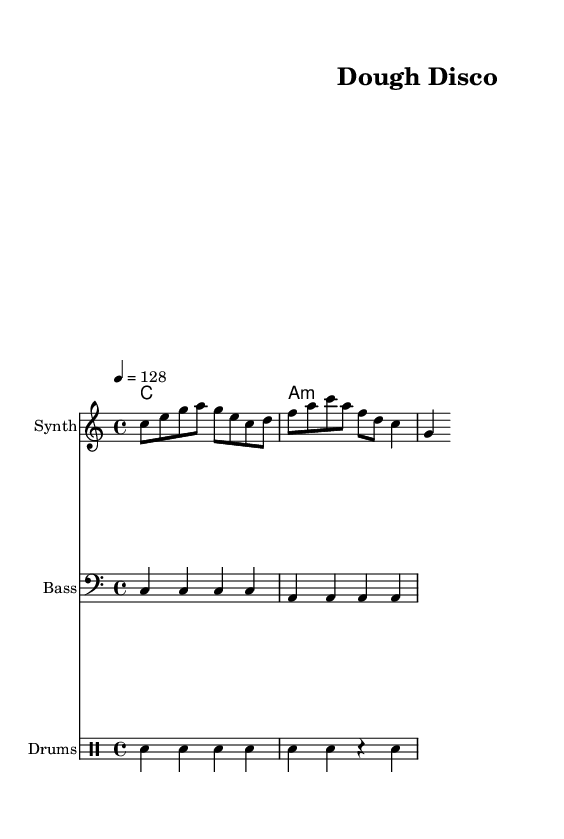What is the key signature of this music? The key signature is indicated at the beginning of the staff. It shows no sharps or flats, confirming it is in C major.
Answer: C major What is the time signature of this music? The time signature is shown at the beginning of the staff and is represented as 4 over 4, indicating four beats per measure, with the quarter note receiving one beat.
Answer: 4/4 What is the tempo marking of this piece? The tempo marking is displayed in beats per minute, indicated as 128. This specifies the speed at which the piece should be played.
Answer: 128 How many measures are present in the melody section? Counting the measures in the melody line reveals that there are two measures of music shown in the score.
Answer: 2 Which instrument is assigned to play the bass part? The bass part is specified at the beginning of the respective staff which is labeled as "Bass." This indicates that the bass clef part is intended for a bass instrument.
Answer: Bass What type of musical texture is primarily used in this piece? The music features a layered texture commonly found in dance music, with distinct parts for melody, harmonies, bass, and drums. The synthesis and layering create an upbeat electronic dance feel.
Answer: Layered texture What rhythmic pattern do the drums follow in the first measure? The drumming pattern begins with a bass drum on beats 1 and 3 and a hi-hat on beats 2 and 4, defining an energetic dance rhythm typical for electronic music.
Answer: Kick, Hi-hat 